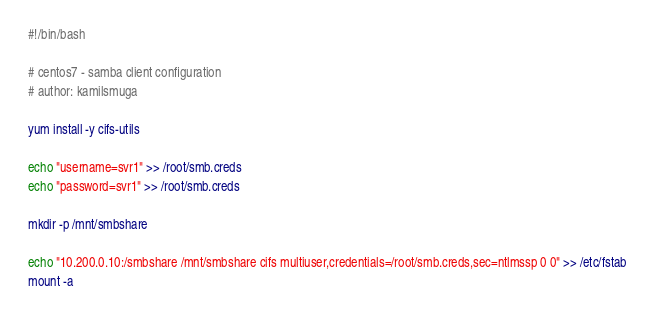Convert code to text. <code><loc_0><loc_0><loc_500><loc_500><_Bash_>#!/bin/bash

# centos7 - samba client configuration 
# author: kamilsmuga

yum install -y cifs-utils

echo "username=svr1" >> /root/smb.creds
echo "password=svr1" >> /root/smb.creds

mkdir -p /mnt/smbshare

echo "10.200.0.10:/smbshare /mnt/smbshare cifs multiuser,credentials=/root/smb.creds,sec=ntlmssp 0 0" >> /etc/fstab
mount -a
</code> 